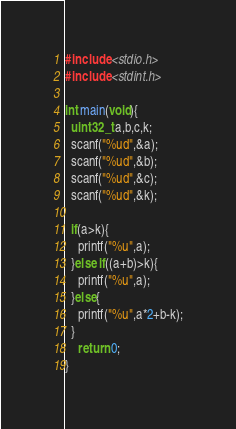<code> <loc_0><loc_0><loc_500><loc_500><_C_>#include <stdio.h>
#include <stdint.h>

int main(void){
  uint32_t a,b,c,k;
  scanf("%ud",&a);
  scanf("%ud",&b);
  scanf("%ud",&c);
  scanf("%ud",&k);
  
  if(a>k){
    printf("%u",a);
  }else if((a+b)>k){
  	printf("%u",a);
  }else{
  	printf("%u",a*2+b-k);
  }
  	return 0;
}</code> 